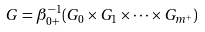<formula> <loc_0><loc_0><loc_500><loc_500>G = \beta _ { 0 + } ^ { - 1 } ( G _ { 0 } \times G _ { 1 } \times \cdots \times G _ { m ^ { + } } )</formula> 